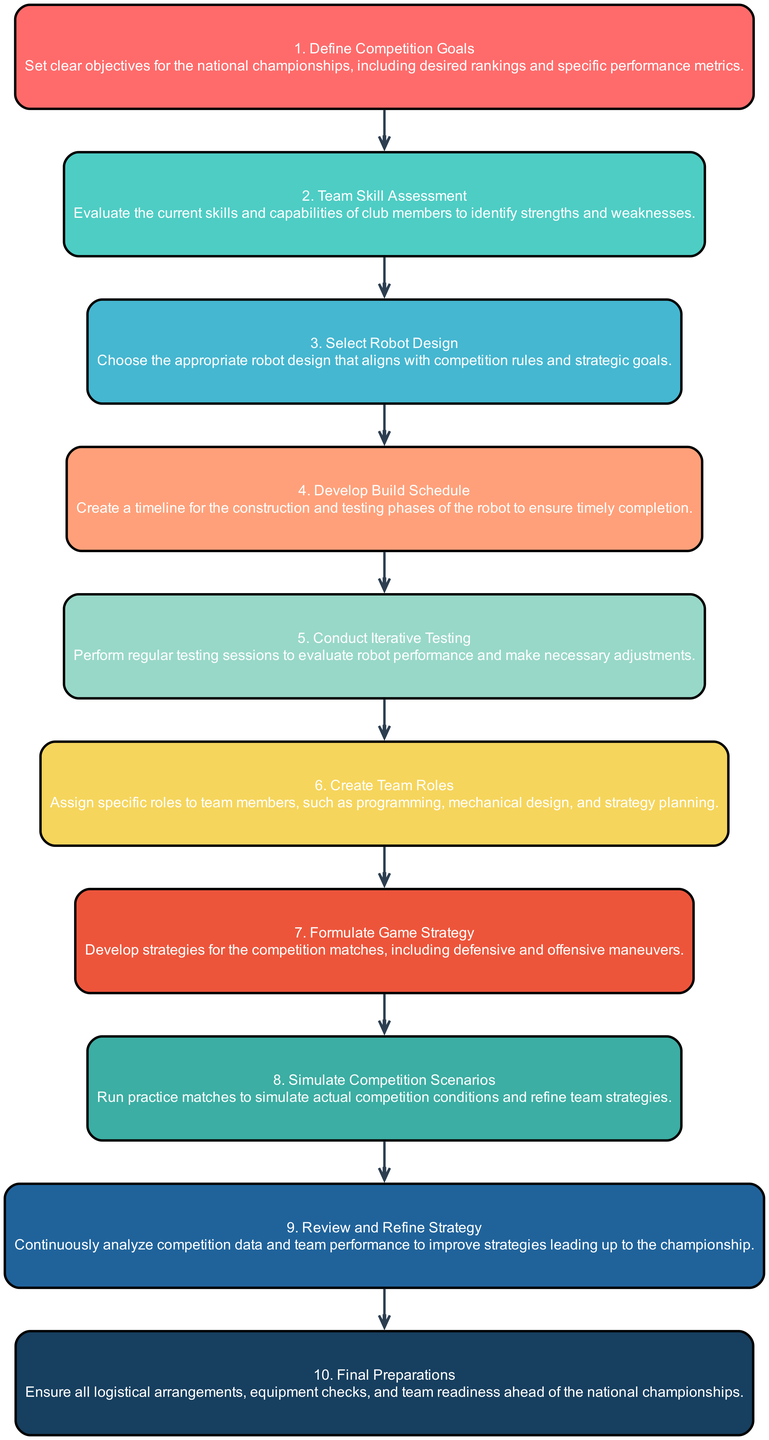What is the first step in the sequence? The first step is represented by the first node, which is "Define Competition Goals". This node outlines the initial action in the strategy development process.
Answer: Define Competition Goals How many total nodes are present in the diagram? The diagram contains a total of 10 nodes, as there are 10 elements listed in the data. Each node represents a step in the strategy sequence.
Answer: 10 Which step comes after "Team Skill Assessment"? The step that follows "Team Skill Assessment" is "Select Robot Design". This is determined by looking at the flow of the edges connecting the nodes.
Answer: Select Robot Design What is the last action in the sequence? The last action outlined in the diagram is "Final Preparations", indicating the concluding phase before the competition.
Answer: Final Preparations How many edges connect the nodes in the diagram? There are 9 edges connecting the nodes in the sequence diagram, as each of the 10 nodes connects to the next one until the last step.
Answer: 9 Which nodes are directly linked to "Develop Build Schedule"? "Develop Build Schedule" is directly linked to "Select Robot Design" (previous) and "Conduct Iterative Testing" (next). Analyzing the edges associated with "Develop Build Schedule" gives these connections.
Answer: Select Robot Design, Conduct Iterative Testing What relationships exist between "Formulate Game Strategy" and "Simulate Competition Scenarios"? "Formulate Game Strategy" leads directly to "Simulate Competition Scenarios", indicating that the formulation of strategy is prior to simulating those strategies in practice. The edge connects these two steps.
Answer: Direct link What are the unique characteristics of this sequence diagram? The sequence diagram uniquely represents the order of steps in a process and illustrates how each step leads to the subsequent one, providing a clear flow from goal definition to final preparations.
Answer: Order of steps, clear flow 